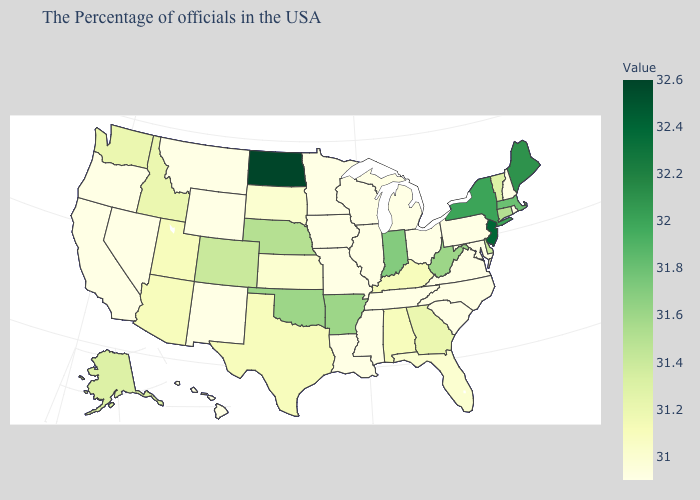Which states have the lowest value in the West?
Keep it brief. Wyoming, New Mexico, Montana, Nevada, California, Oregon, Hawaii. Among the states that border Delaware , does Maryland have the lowest value?
Concise answer only. Yes. Among the states that border North Dakota , which have the highest value?
Short answer required. South Dakota. Does the map have missing data?
Concise answer only. No. Which states hav the highest value in the MidWest?
Give a very brief answer. North Dakota. Among the states that border Oklahoma , does Texas have the lowest value?
Give a very brief answer. No. Does North Dakota have the lowest value in the USA?
Short answer required. No. 